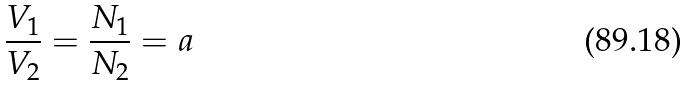Convert formula to latex. <formula><loc_0><loc_0><loc_500><loc_500>\frac { V _ { 1 } } { V _ { 2 } } = \frac { N _ { 1 } } { N _ { 2 } } = a</formula> 